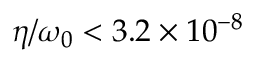Convert formula to latex. <formula><loc_0><loc_0><loc_500><loc_500>\eta / \omega _ { 0 } < 3 . 2 \times 1 0 ^ { - 8 }</formula> 